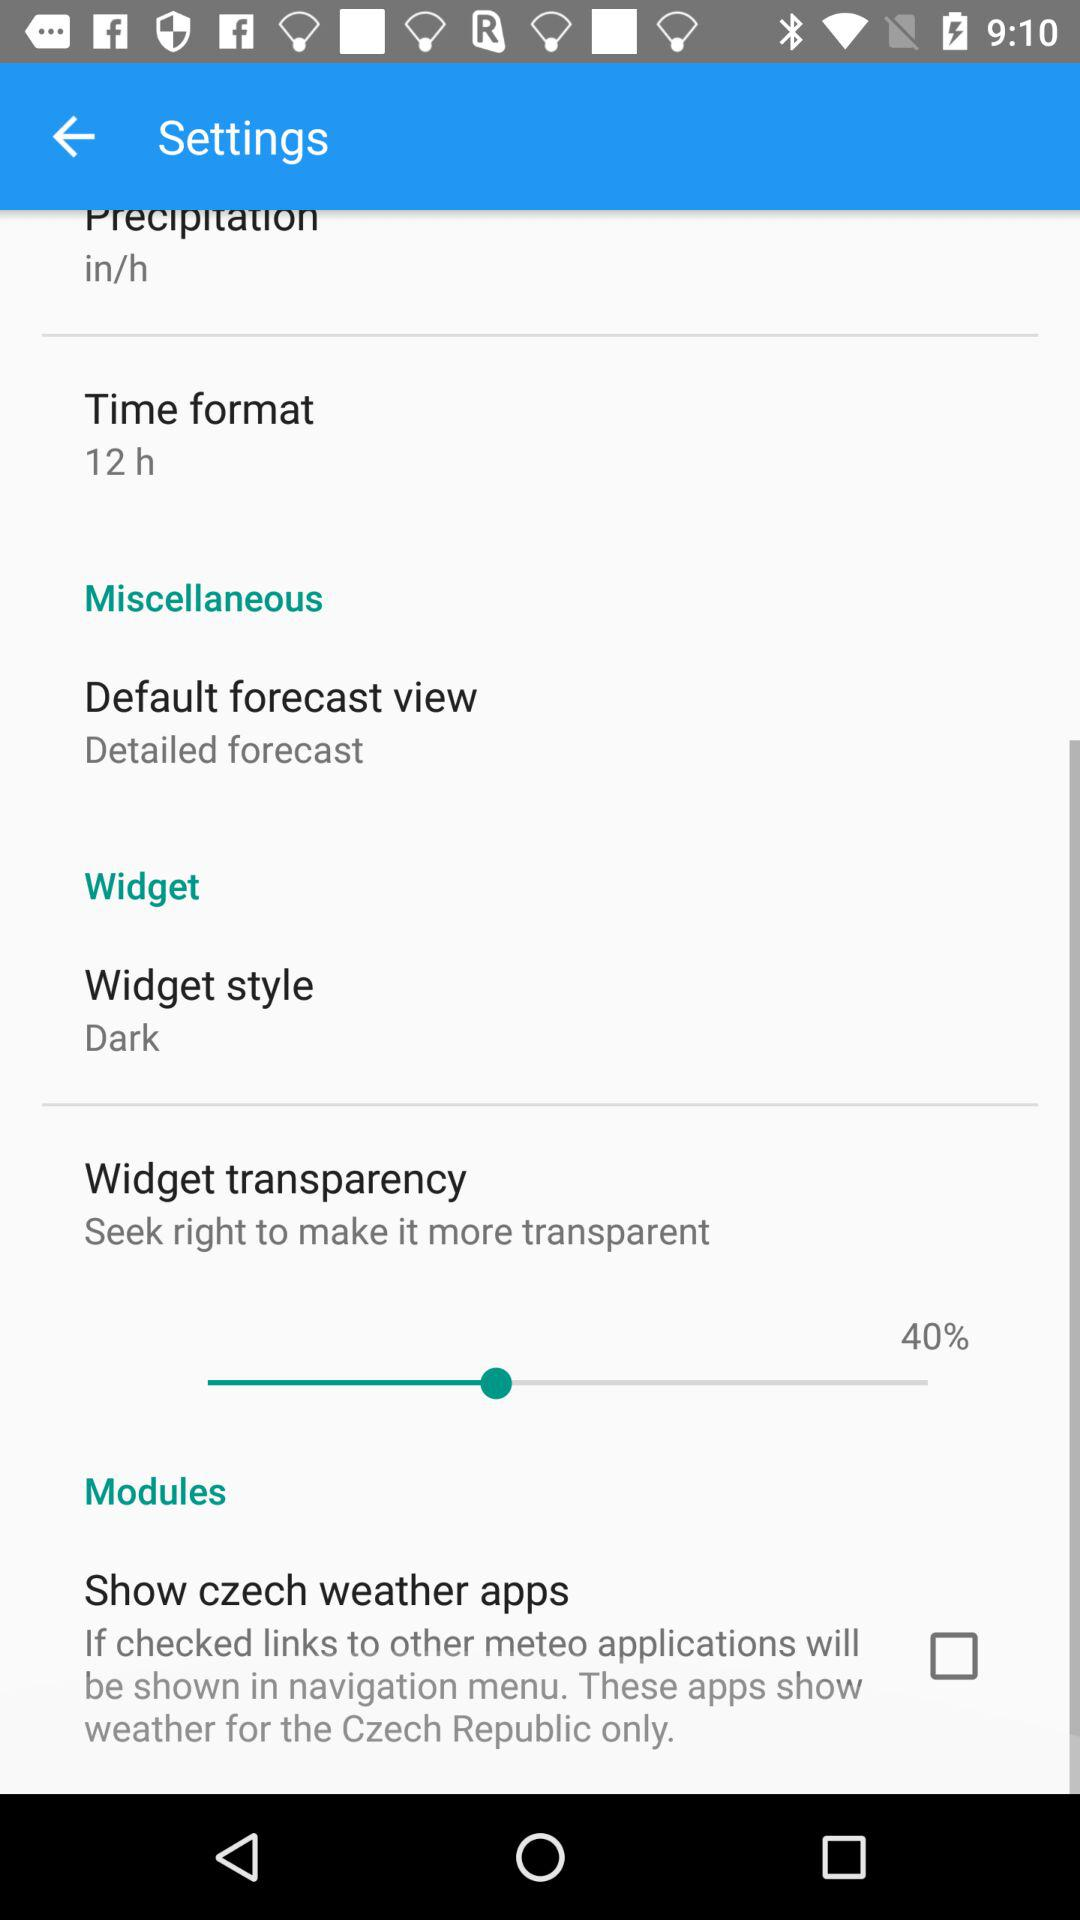What is the time format? The time format is 12 h. 